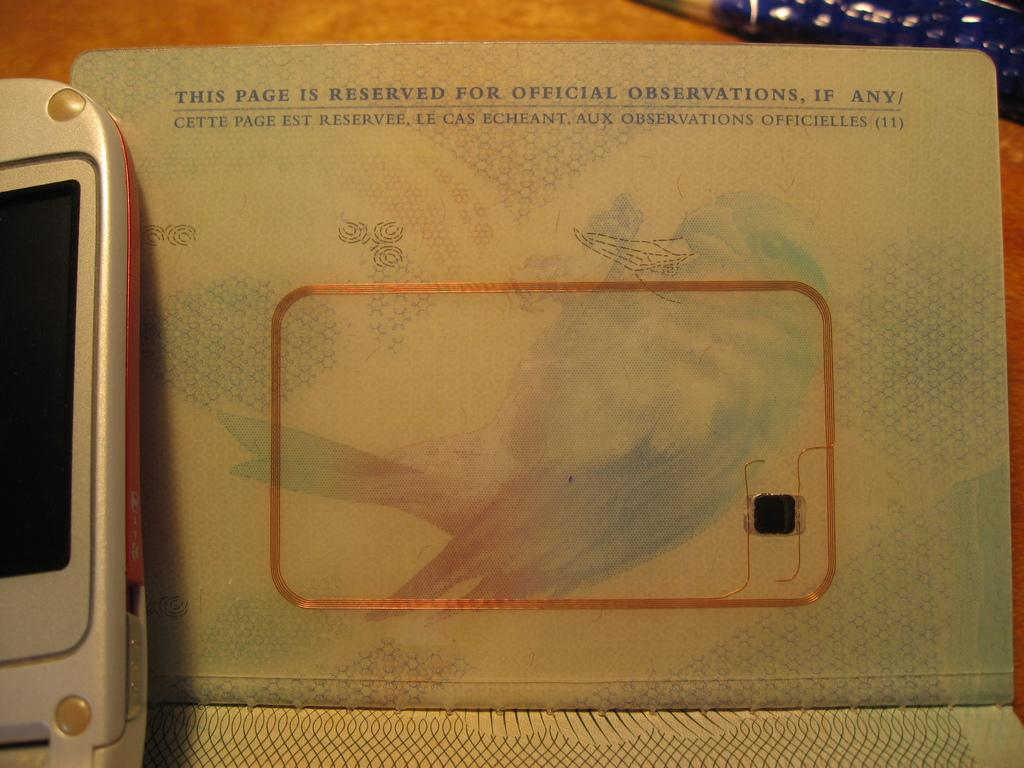<image>
Render a clear and concise summary of the photo. A passport is opened to a page that says "This page is reserved for official observations, if any" 